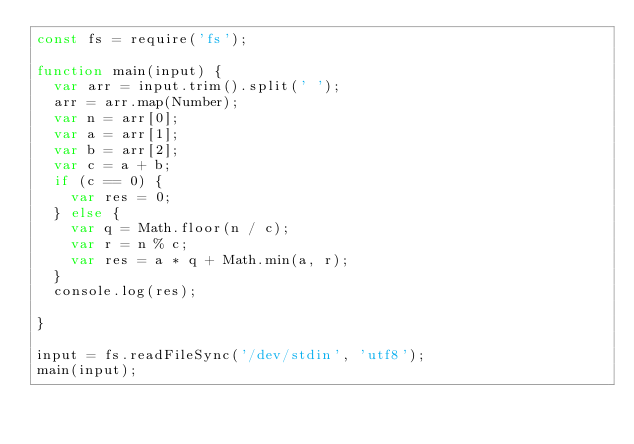Convert code to text. <code><loc_0><loc_0><loc_500><loc_500><_JavaScript_>const fs = require('fs');

function main(input) {
  var arr = input.trim().split(' ');
  arr = arr.map(Number);
  var n = arr[0];
  var a = arr[1];
  var b = arr[2];
  var c = a + b;
  if (c == 0) {
    var res = 0;
  } else {
    var q = Math.floor(n / c);
    var r = n % c;
    var res = a * q + Math.min(a, r);
  }
  console.log(res);

}

input = fs.readFileSync('/dev/stdin', 'utf8');
main(input);</code> 